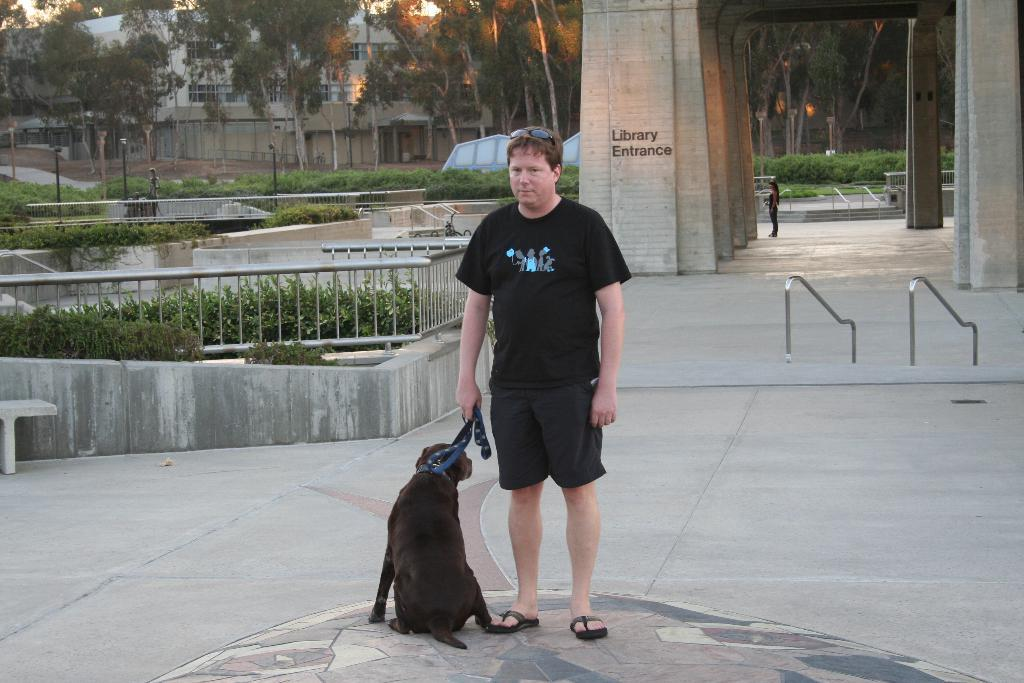What is the person in the image doing? The person is standing with a dog in the image. Where are they standing? They are standing on a road. What can be seen in the background of the image? There are many plants and a building visible in the image. What type of meat is the person grilling in the image? There is no meat or grill present in the image. How does the wind affect the person and the dog in the image? The image does not show any wind or its effects on the person and the dog. 